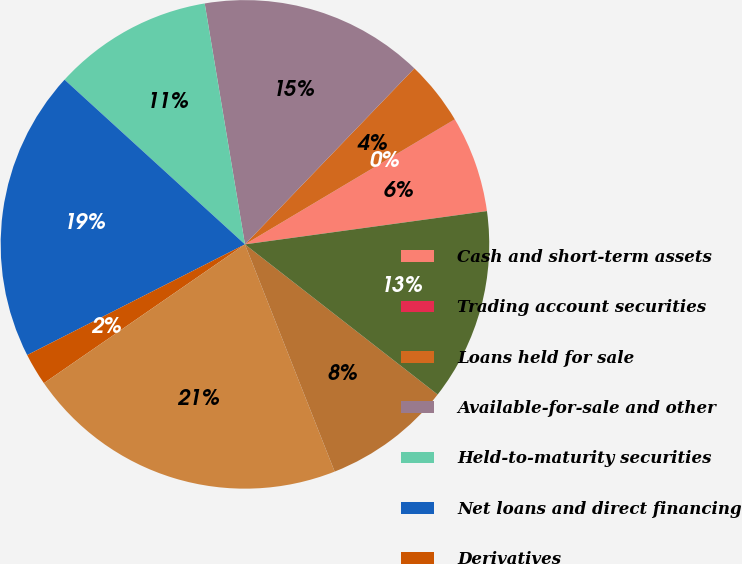Convert chart to OTSL. <chart><loc_0><loc_0><loc_500><loc_500><pie_chart><fcel>Cash and short-term assets<fcel>Trading account securities<fcel>Loans held for sale<fcel>Available-for-sale and other<fcel>Held-to-maturity securities<fcel>Net loans and direct financing<fcel>Derivatives<fcel>Deposits<fcel>Short-term borrowings<fcel>Long term debt<nl><fcel>6.36%<fcel>0.02%<fcel>4.25%<fcel>14.83%<fcel>10.59%<fcel>19.26%<fcel>2.13%<fcel>21.37%<fcel>8.48%<fcel>12.71%<nl></chart> 